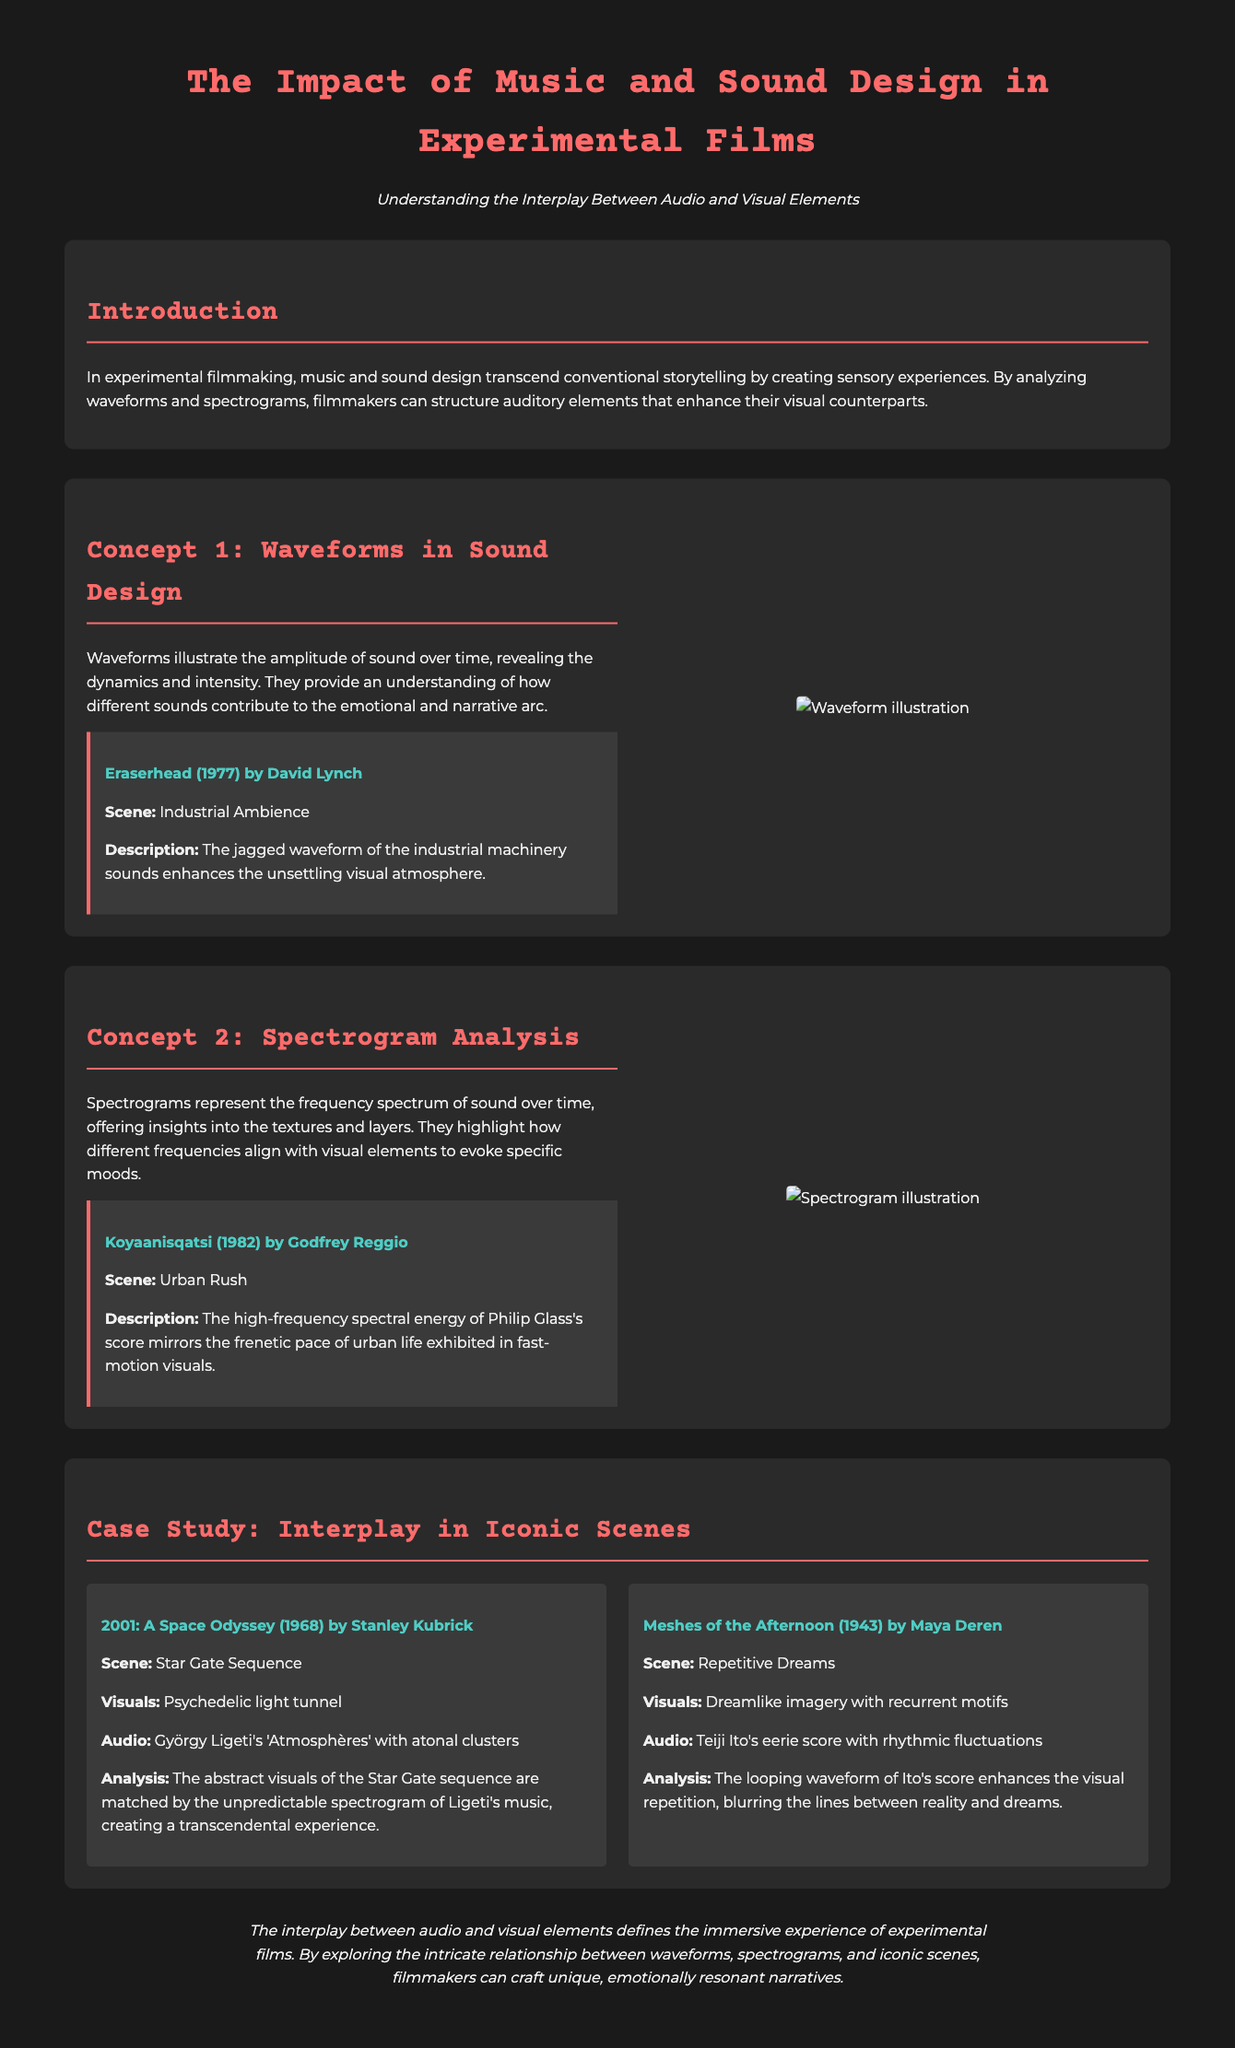What is the title of the document? The title of the document is stated at the top of the page.
Answer: The Impact of Music and Sound Design in Experimental Films Who directed "Eraserhead"? The director of "Eraserhead" is mentioned in the description of the film.
Answer: David Lynch What year was "Koyaanisqatsi" released? The release year of "Koyaanisqatsi" is noted in the document.
Answer: 1982 What visual aspect is enhanced by the waveform in "Eraserhead"? The document describes the impact of sound on the visual atmosphere in "Eraserhead."
Answer: Unsettling visual atmosphere How is the audio of Philip Glass's score characterized? The document explains the frequency characteristics of the score during a specific scene.
Answer: High-frequency spectral energy What is the primary focus of the "Case Study" section? The document outlines the purpose of the case study section, focusing on examples.
Answer: Interplay in Iconic Scenes What is one of the musical works analyzed in the Star Gate sequence? The document states the title of the specific music piece used during a notable scene.
Answer: 'Atmosphères' What type of imagery is used in "Meshes of the Afternoon"? The document specifies the style of visuals employed in the film.
Answer: Dreamlike imagery 